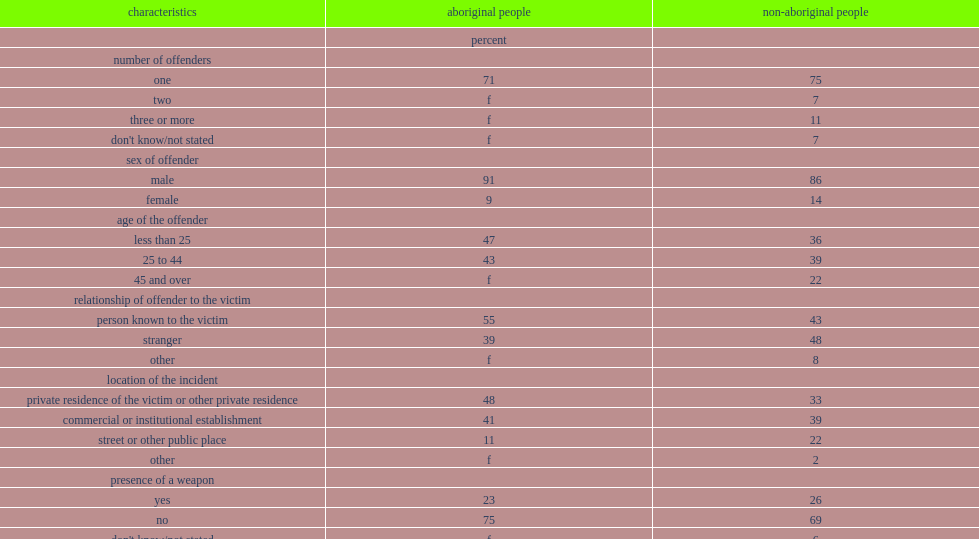In 2014, what was the percent of non-spousal violent incidents against aboriginal people involved one offender? 71.0. In 2014, what was the percent of non-spousal violent incidents against non-aboriginal people involved one offender? 75.0. What was the percent of aboriginal victims reported that they knew their attacker? 55.0. What was the percent of non-aboriginal victims of non-spousal violence reported that they knew their attacker? 43.0. What was the percent of incidents involving aboriginal victims took place in a residence? 48.0. What was the percent of incidents involving aboriginal victims took place in a commercial/institutional establishment? 41.0. What was the proportion of incidents involving an aboriginal victim took place in the street or some other public place? 11.0. What was the proportion of incidents involving an non-aboriginal victim took place in the street or some other public place? 22.0. Among aboriginal people that were the victim of a non-spousal violent crime, what was the percent of people reported that they believed the incident was related to the offender's alcohol or drug use? 69.0. Among non-aboriginal people that were the victim of a non-spousal violent crime, what was the percent of people reported that they believed the incident was related to the offender's alcohol or drug use? 52.0. What was the percent of aboriginal victims in a non-spousal violent incident reported no physical injuries? 83.0. What was the percent of non-aboriginal victims in a non-spousal violent incident reported no physical injuries? 80.0. 